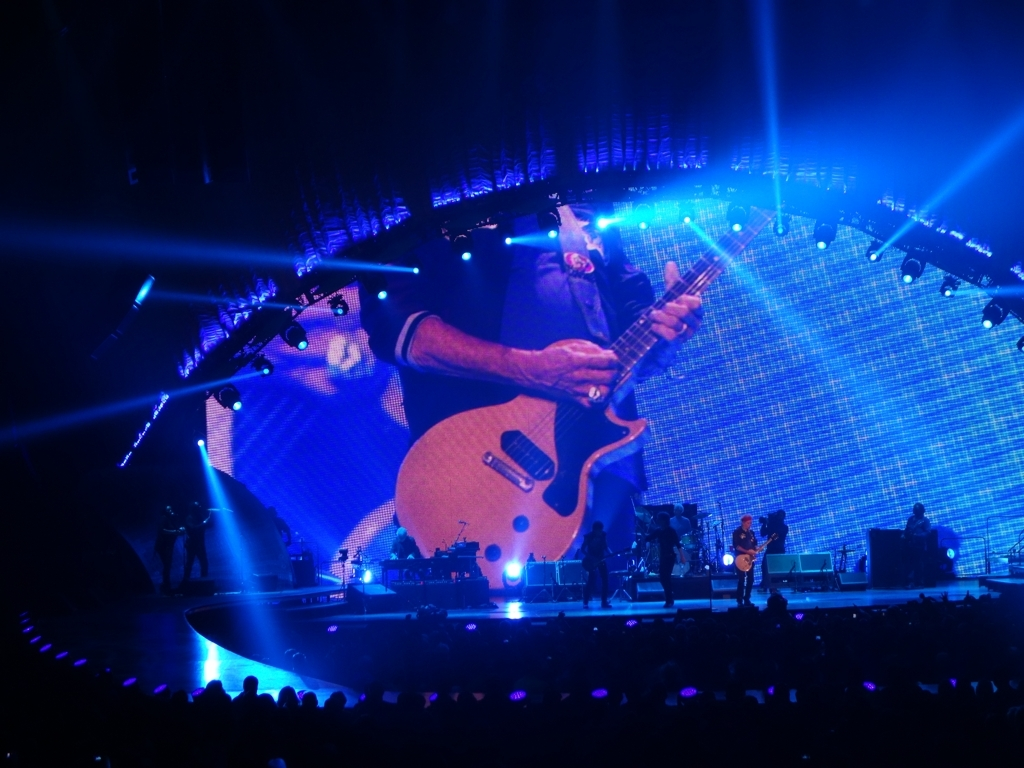What kind of event is being depicted in the image? The image captures a moment during a live music concert, featuring a musician performing on stage with a guitar, with bright stage lighting and an audience in the foreground. What is the mood of the crowd like from what you can see? The audience appears captivated and focused on the performance, which suggests they are enjoying the experience and the atmosphere seems lively and engaged. 